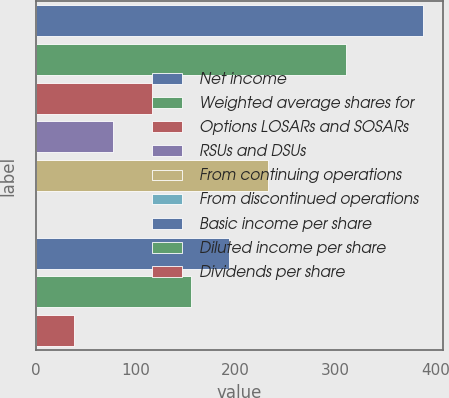Convert chart. <chart><loc_0><loc_0><loc_500><loc_500><bar_chart><fcel>Net income<fcel>Weighted average shares for<fcel>Options LOSARs and SOSARs<fcel>RSUs and DSUs<fcel>From continuing operations<fcel>From discontinued operations<fcel>Basic income per share<fcel>Diluted income per share<fcel>Dividends per share<nl><fcel>388<fcel>310.39<fcel>116.44<fcel>77.65<fcel>232.81<fcel>0.07<fcel>194.02<fcel>155.23<fcel>38.86<nl></chart> 